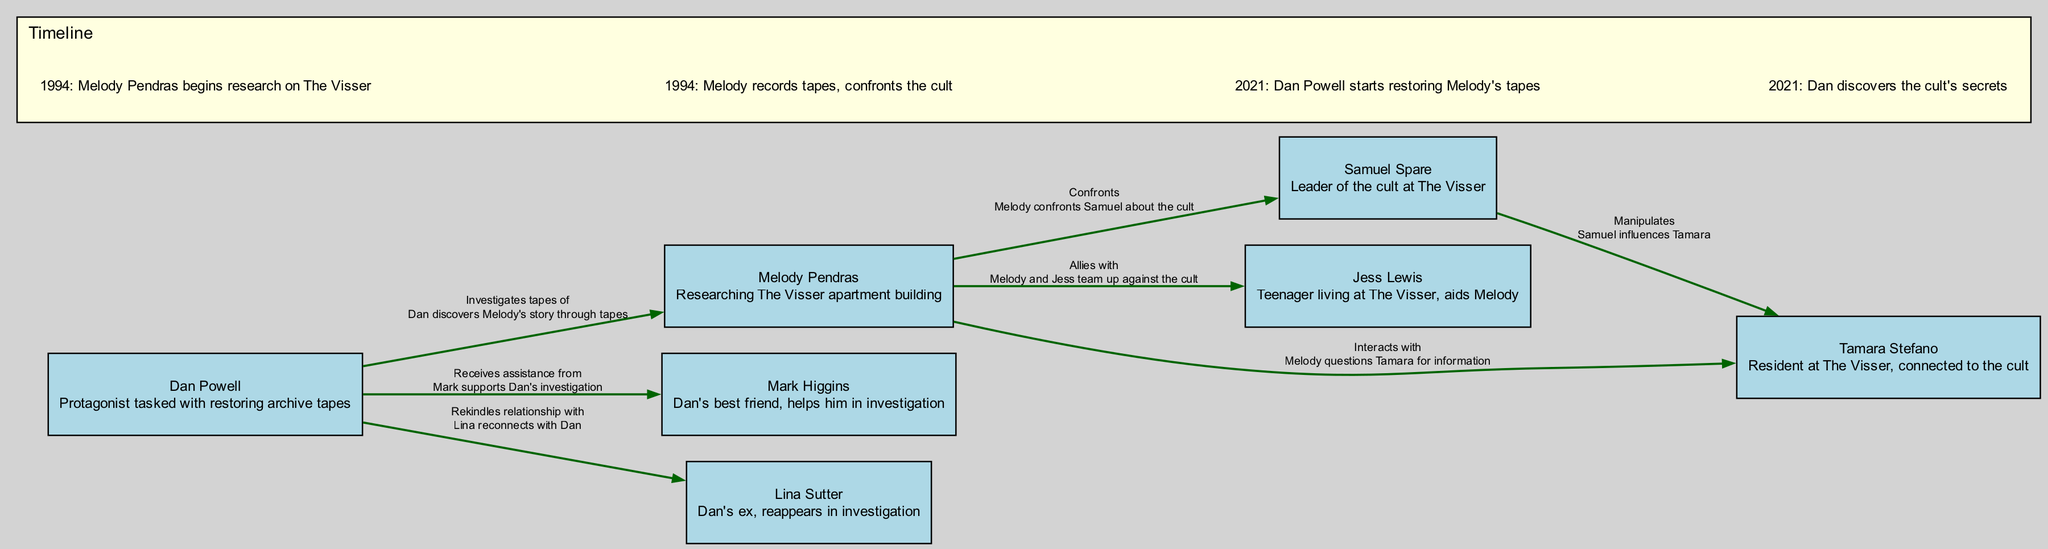What is the number of nodes in the diagram? The diagram consists of a total of seven nodes representing different characters. These nodes are Dan Powell, Melody Pendras, Mark Higgins, Lina Sutter, Samuel Spare, Jess Lewis, and Tamara Stefano.
Answer: 7 Who does Dan Powell receive assistance from? According to the diagram, the edge between Dan Powell and Mark Higgins indicates that Mark assists Dan in his investigation.
Answer: Mark Higgins What year does Melody Pendras begin her research on The Visser? The timeline section of the diagram states that Melody Pendras begins her research in the year 1994.
Answer: 1994 What relationship does Melody Pendras have with Jess Lewis? The diagram shows an edge labeled "Allies with" connecting Melody Pendras and Jess Lewis, indicating they team up together.
Answer: Allies Who confronts Samuel Spare according to the diagram? The diagram shows an edge from Melody Pendras to Samuel Spare labeled "Confronts", indicating that she is the character who confronts him about the cult.
Answer: Melody Pendras What is a key event that occurs in 2021 according to the timeline? The timeline specifies a significant event in 2021 where Dan Powell starts restoring Melody's tapes. This is crucial as it connects Dan to Melody’s narrative.
Answer: Dan Powell starts restoring Melody's tapes How many edges are present in the diagram? The diagram contains a total of seven edges representing relationships or actions between the characters. By counting each arrow or line linking the nodes, we find that there are indeed seven connections.
Answer: 7 Which character is manipulated by Samuel Spare? The diagram indicates that there is a connection labeled "Manipulates" from Samuel Spare to Tamara Stefano, showing that he influences her actions or beliefs.
Answer: Tamara Stefano What significant change happens in Dan's relationship with Lina Sutter? The diagram shows an edge from Dan Powell to Lina Sutter labeled "Rekindles relationship with", which signifies that their relationship is revisited during the course of the investigation.
Answer: Rekindles relationship with 